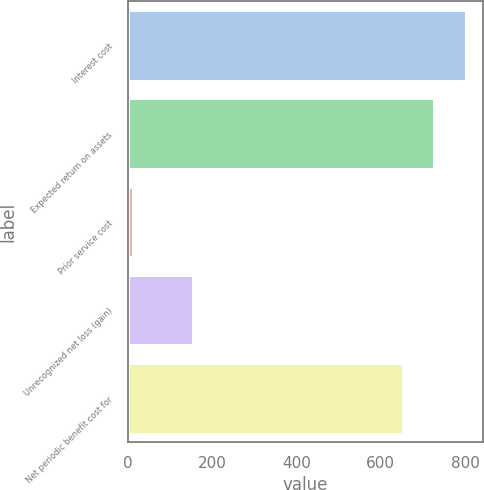Convert chart to OTSL. <chart><loc_0><loc_0><loc_500><loc_500><bar_chart><fcel>Interest cost<fcel>Expected return on assets<fcel>Prior service cost<fcel>Unrecognized net loss (gain)<fcel>Net periodic benefit cost for<nl><fcel>801.8<fcel>727.4<fcel>13<fcel>154<fcel>653<nl></chart> 